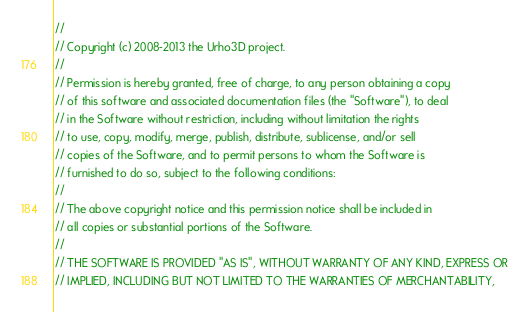Convert code to text. <code><loc_0><loc_0><loc_500><loc_500><_C_>//
// Copyright (c) 2008-2013 the Urho3D project.
//
// Permission is hereby granted, free of charge, to any person obtaining a copy
// of this software and associated documentation files (the "Software"), to deal
// in the Software without restriction, including without limitation the rights
// to use, copy, modify, merge, publish, distribute, sublicense, and/or sell
// copies of the Software, and to permit persons to whom the Software is
// furnished to do so, subject to the following conditions:
//
// The above copyright notice and this permission notice shall be included in
// all copies or substantial portions of the Software.
//
// THE SOFTWARE IS PROVIDED "AS IS", WITHOUT WARRANTY OF ANY KIND, EXPRESS OR
// IMPLIED, INCLUDING BUT NOT LIMITED TO THE WARRANTIES OF MERCHANTABILITY,</code> 